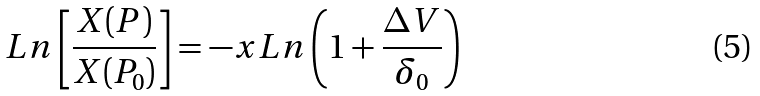<formula> <loc_0><loc_0><loc_500><loc_500>L n \left [ \frac { X ( P ) } { X ( P _ { 0 } ) } \right ] = - x L n \left ( 1 + \frac { \Delta V } { \delta _ { 0 } } \right )</formula> 